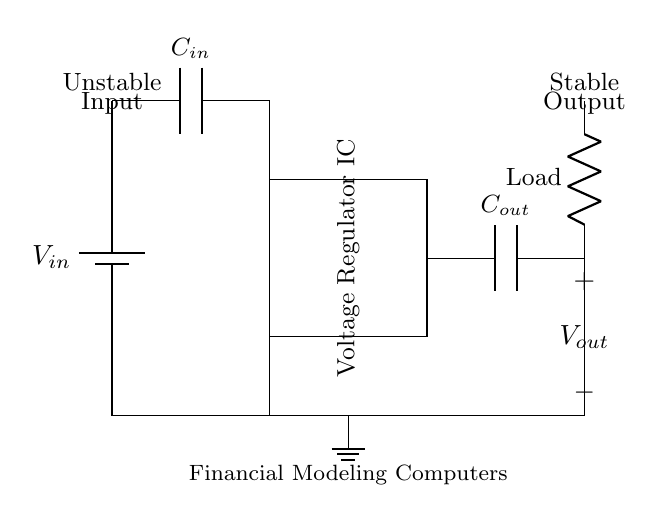What is the input component in this circuit? The input component is the capacitor labeled as C_in, which connects the input voltage to the voltage regulator. It helps filter out noise from the voltage source before regulation.
Answer: C_in What is the function of the voltage regulator IC? The voltage regulator IC is designed to provide a stable output voltage, despite variations in input voltage or load conditions. It regulates the voltage to ensure consistent power supply to the load.
Answer: Stabilization What type of output voltage is produced by this circuit? The output is designed to be stable, meaning the voltage is kept consistent regardless of fluctuations in the input voltage or current demand. This is essential for powering sensitive devices like computers.
Answer: Stable What is the purpose of the output capacitor labeled C_out? The output capacitor C_out smooths the output voltage, reducing voltage ripple and transient response, thereby enhancing stability and performance for the connected load.
Answer: Smoothing How many components in total are used in this voltage regulator circuit? The components include one battery, one voltage regulator IC, two capacitors C_in and C_out, one load resistor, and a ground connection. Adding these up gives a total count of five components.
Answer: Five What is the indicative role of the ground in this circuit? The ground serves as a reference point for the voltage levels in the circuit and ensures a complete electrical connection, allowing current to flow effectively between components and providing a stable baseline for measurements.
Answer: Reference 